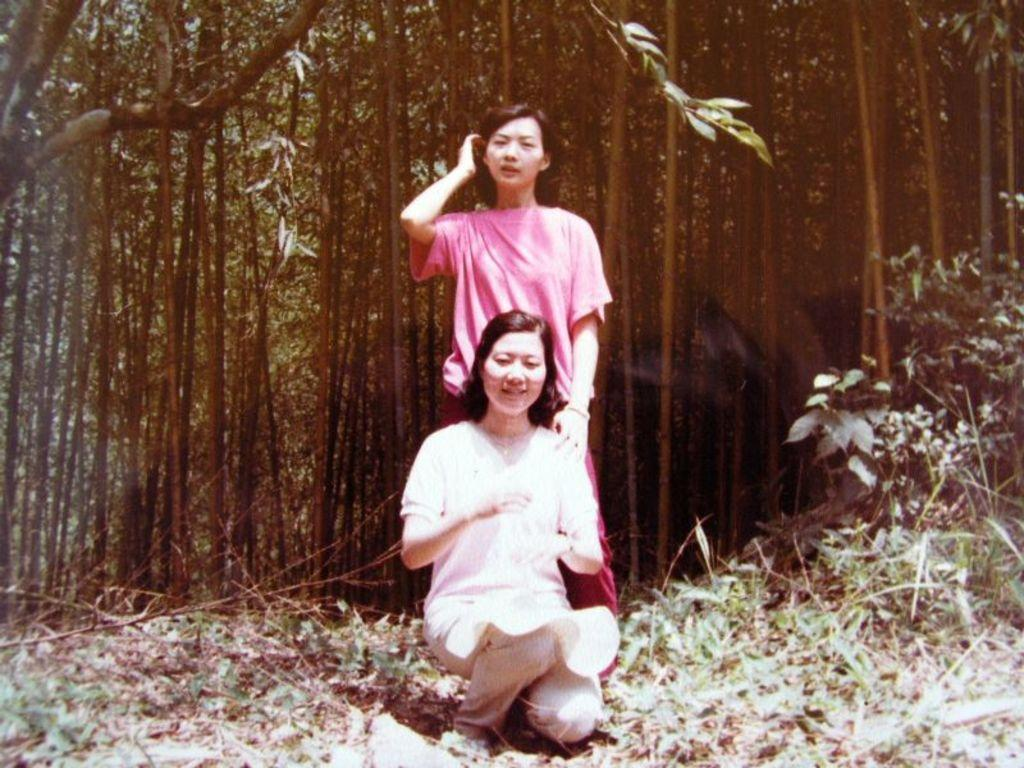How many people are in the image? There are two women in the image. What is the position of the women in the image? The women are on the ground. What can be seen in the background of the image? There are trees and grass in the background of the image. What type of flock is visible in the image? There is no flock present in the image. What is the son of one of the women doing in the image? There is no son present in the image. 